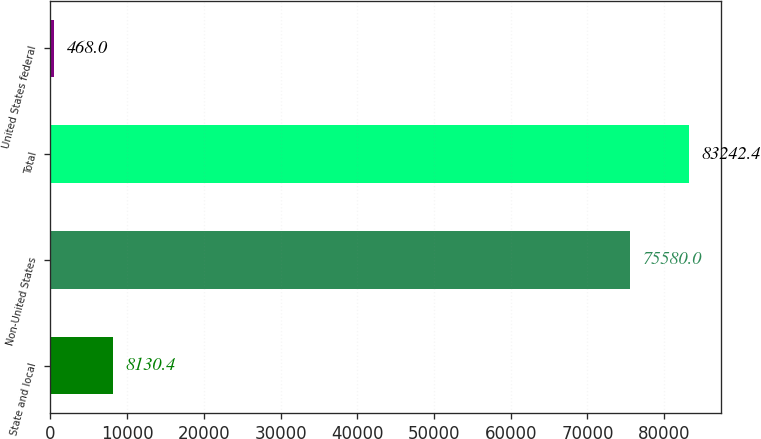Convert chart to OTSL. <chart><loc_0><loc_0><loc_500><loc_500><bar_chart><fcel>State and local<fcel>Non-United States<fcel>Total<fcel>United States federal<nl><fcel>8130.4<fcel>75580<fcel>83242.4<fcel>468<nl></chart> 